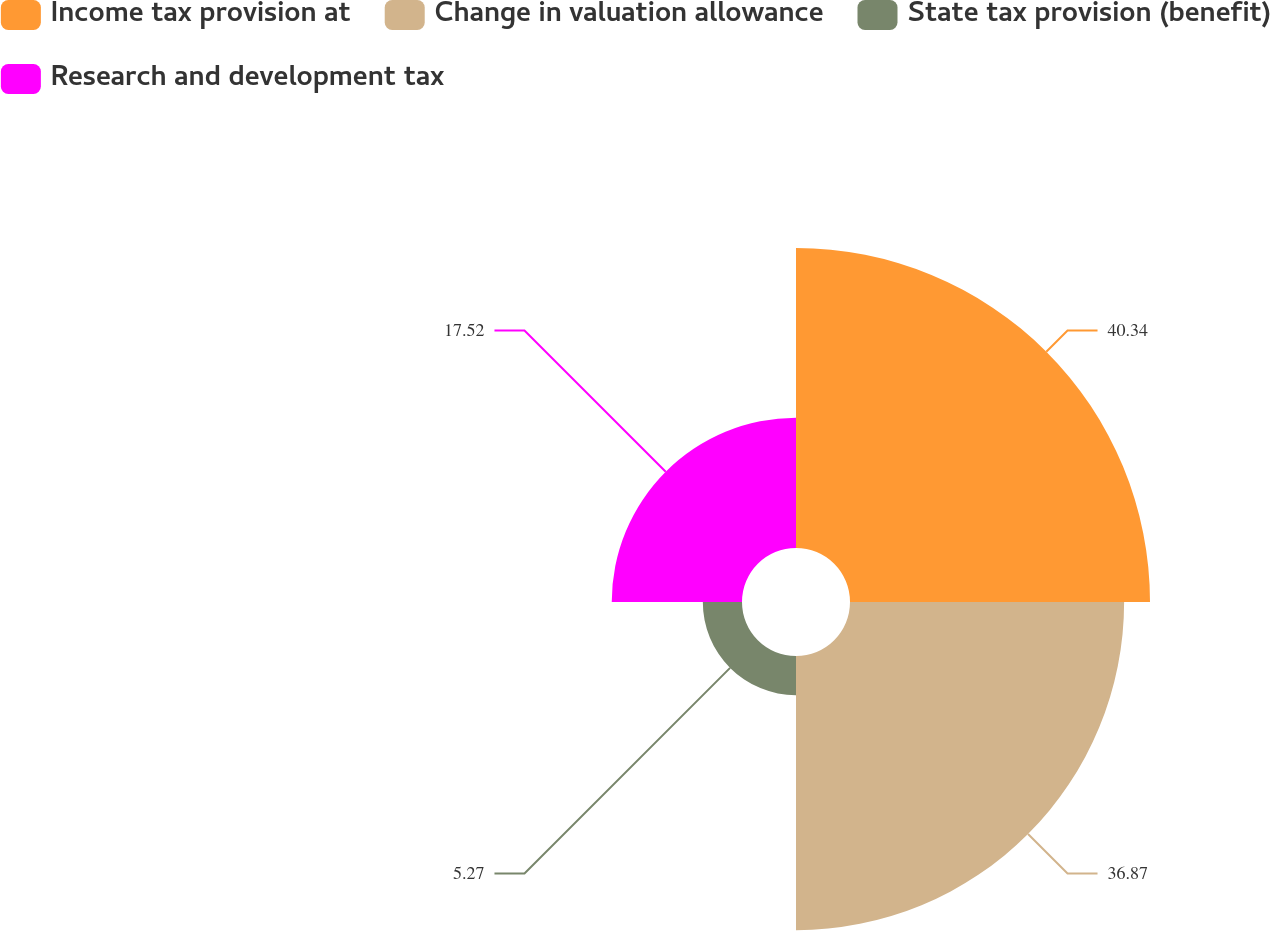<chart> <loc_0><loc_0><loc_500><loc_500><pie_chart><fcel>Income tax provision at<fcel>Change in valuation allowance<fcel>State tax provision (benefit)<fcel>Research and development tax<nl><fcel>40.35%<fcel>36.87%<fcel>5.27%<fcel>17.52%<nl></chart> 